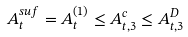<formula> <loc_0><loc_0><loc_500><loc_500>A _ { t } ^ { s u f } = A _ { t } ^ { ( 1 ) } \leq A _ { t , 3 } ^ { c } \leq A _ { t , 3 } ^ { D }</formula> 